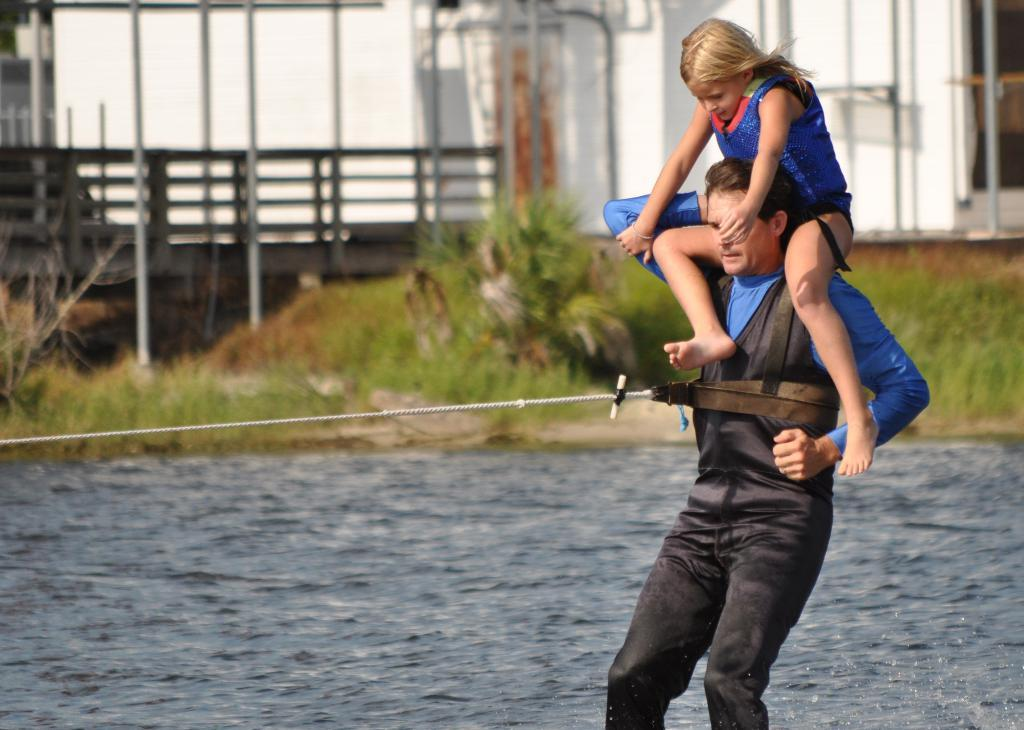What is the man in the image doing? The man is standing in the image, and a girl is sitting on his shoulders. What is the girl doing while sitting on the man's shoulders? The girl is sitting on the man's shoulders. What can be seen in the background of the image? There is water visible in the image. What type of surface is under the man and girl? There is grass on the ground in the image. What is the purpose of the fence in the image? The fence is present in the image, but its purpose is not explicitly stated. What type of appliance is being used by the girl to sail across the water in the image? There is no appliance or sail present in the image; the girl is sitting on the man's shoulders. 